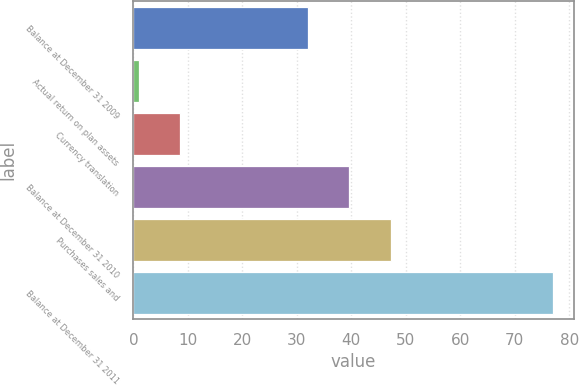Convert chart to OTSL. <chart><loc_0><loc_0><loc_500><loc_500><bar_chart><fcel>Balance at December 31 2009<fcel>Actual return on plan assets<fcel>Currency translation<fcel>Balance at December 31 2010<fcel>Purchases sales and<fcel>Balance at December 31 2011<nl><fcel>32<fcel>1<fcel>8.6<fcel>39.6<fcel>47.2<fcel>77<nl></chart> 